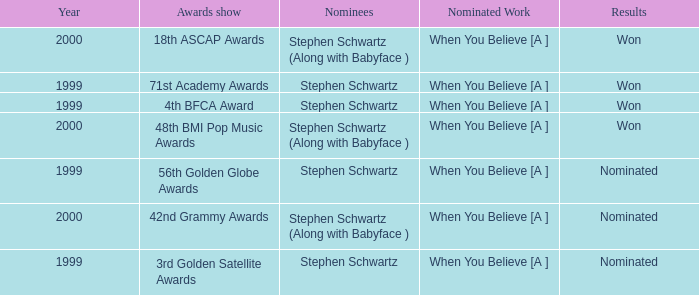What was the results of the 71st Academy Awards show? Won. 